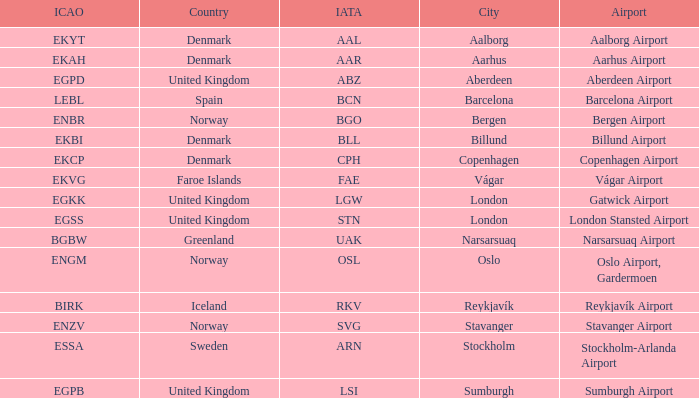What airport has an ICAO of Birk? Reykjavík Airport. 